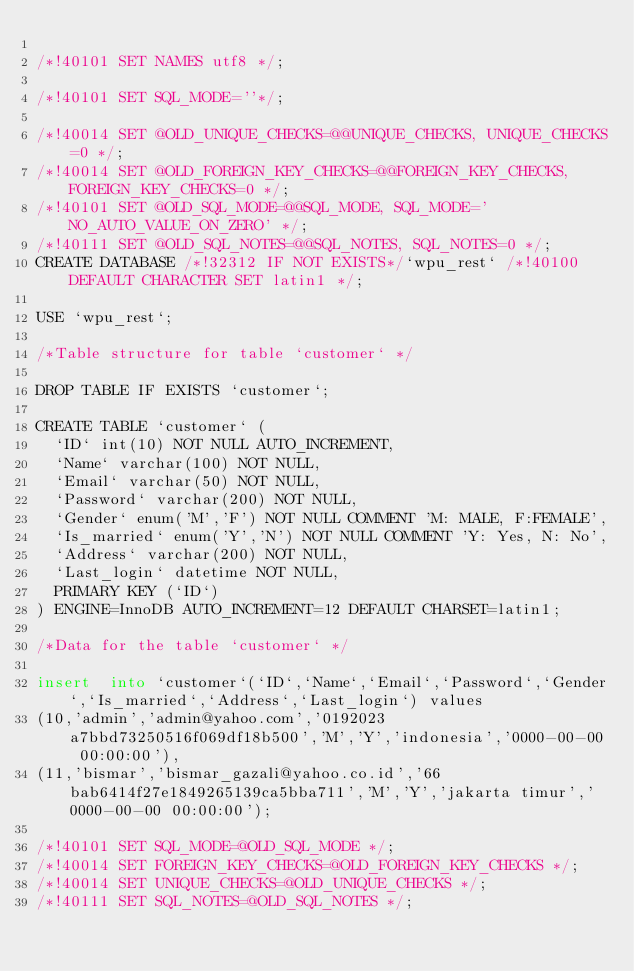<code> <loc_0><loc_0><loc_500><loc_500><_SQL_>
/*!40101 SET NAMES utf8 */;

/*!40101 SET SQL_MODE=''*/;

/*!40014 SET @OLD_UNIQUE_CHECKS=@@UNIQUE_CHECKS, UNIQUE_CHECKS=0 */;
/*!40014 SET @OLD_FOREIGN_KEY_CHECKS=@@FOREIGN_KEY_CHECKS, FOREIGN_KEY_CHECKS=0 */;
/*!40101 SET @OLD_SQL_MODE=@@SQL_MODE, SQL_MODE='NO_AUTO_VALUE_ON_ZERO' */;
/*!40111 SET @OLD_SQL_NOTES=@@SQL_NOTES, SQL_NOTES=0 */;
CREATE DATABASE /*!32312 IF NOT EXISTS*/`wpu_rest` /*!40100 DEFAULT CHARACTER SET latin1 */;

USE `wpu_rest`;

/*Table structure for table `customer` */

DROP TABLE IF EXISTS `customer`;

CREATE TABLE `customer` (
  `ID` int(10) NOT NULL AUTO_INCREMENT,
  `Name` varchar(100) NOT NULL,
  `Email` varchar(50) NOT NULL,
  `Password` varchar(200) NOT NULL,
  `Gender` enum('M','F') NOT NULL COMMENT 'M: MALE, F:FEMALE',
  `Is_married` enum('Y','N') NOT NULL COMMENT 'Y: Yes, N: No',
  `Address` varchar(200) NOT NULL,
  `Last_login` datetime NOT NULL,
  PRIMARY KEY (`ID`)
) ENGINE=InnoDB AUTO_INCREMENT=12 DEFAULT CHARSET=latin1;

/*Data for the table `customer` */

insert  into `customer`(`ID`,`Name`,`Email`,`Password`,`Gender`,`Is_married`,`Address`,`Last_login`) values 
(10,'admin','admin@yahoo.com','0192023a7bbd73250516f069df18b500','M','Y','indonesia','0000-00-00 00:00:00'),
(11,'bismar','bismar_gazali@yahoo.co.id','66bab6414f27e1849265139ca5bba711','M','Y','jakarta timur','0000-00-00 00:00:00');

/*!40101 SET SQL_MODE=@OLD_SQL_MODE */;
/*!40014 SET FOREIGN_KEY_CHECKS=@OLD_FOREIGN_KEY_CHECKS */;
/*!40014 SET UNIQUE_CHECKS=@OLD_UNIQUE_CHECKS */;
/*!40111 SET SQL_NOTES=@OLD_SQL_NOTES */;
</code> 